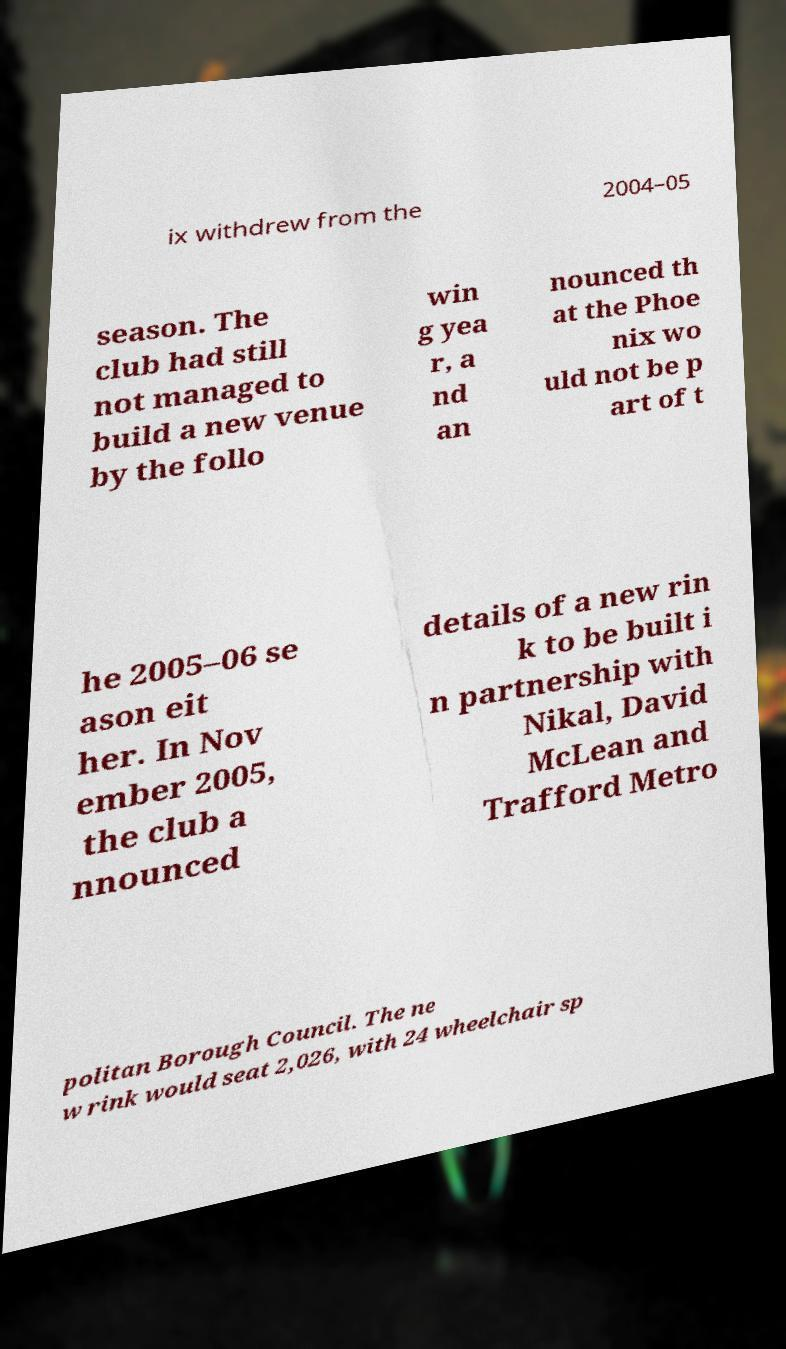For documentation purposes, I need the text within this image transcribed. Could you provide that? ix withdrew from the 2004–05 season. The club had still not managed to build a new venue by the follo win g yea r, a nd an nounced th at the Phoe nix wo uld not be p art of t he 2005–06 se ason eit her. In Nov ember 2005, the club a nnounced details of a new rin k to be built i n partnership with Nikal, David McLean and Trafford Metro politan Borough Council. The ne w rink would seat 2,026, with 24 wheelchair sp 